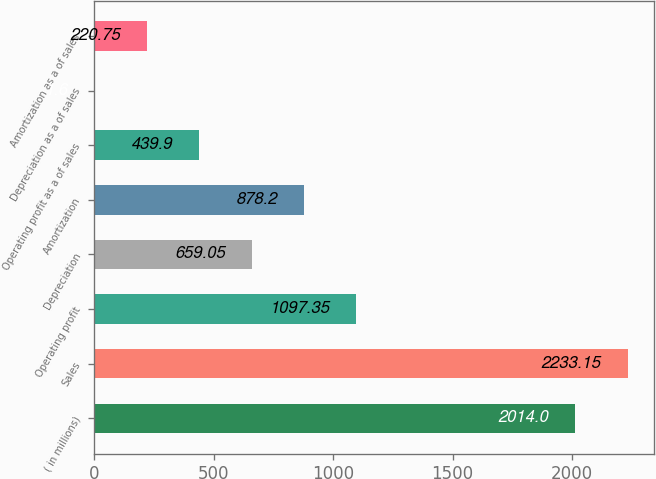Convert chart to OTSL. <chart><loc_0><loc_0><loc_500><loc_500><bar_chart><fcel>( in millions)<fcel>Sales<fcel>Operating profit<fcel>Depreciation<fcel>Amortization<fcel>Operating profit as a of sales<fcel>Depreciation as a of sales<fcel>Amortization as a of sales<nl><fcel>2014<fcel>2233.15<fcel>1097.35<fcel>659.05<fcel>878.2<fcel>439.9<fcel>1.6<fcel>220.75<nl></chart> 